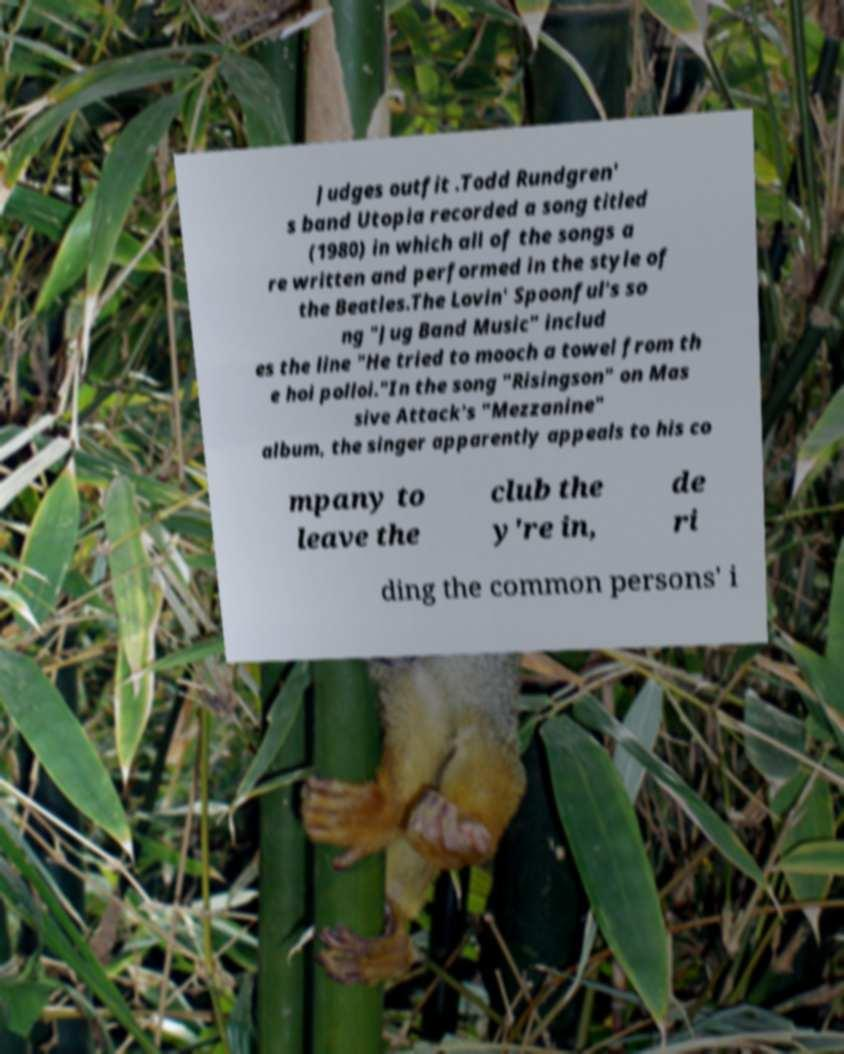Please identify and transcribe the text found in this image. Judges outfit .Todd Rundgren' s band Utopia recorded a song titled (1980) in which all of the songs a re written and performed in the style of the Beatles.The Lovin' Spoonful's so ng "Jug Band Music" includ es the line "He tried to mooch a towel from th e hoi polloi."In the song "Risingson" on Mas sive Attack's "Mezzanine" album, the singer apparently appeals to his co mpany to leave the club the y're in, de ri ding the common persons' i 